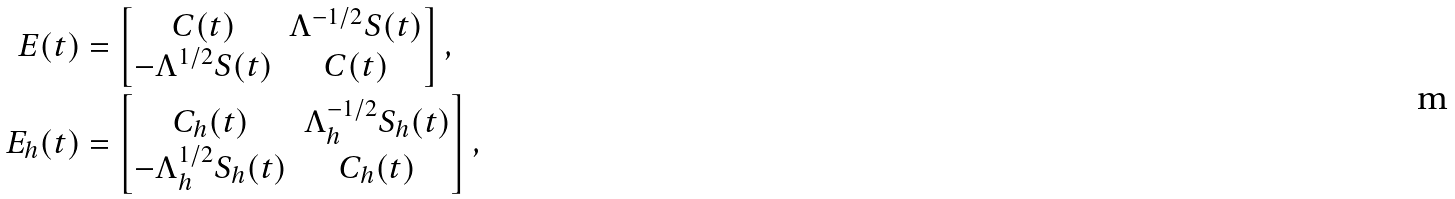Convert formula to latex. <formula><loc_0><loc_0><loc_500><loc_500>E ( t ) & = \begin{bmatrix} C ( t ) & \Lambda ^ { - 1 / 2 } S ( t ) \\ - \Lambda ^ { 1 / 2 } S ( t ) & C ( t ) \end{bmatrix} , \\ E _ { h } ( t ) & = \begin{bmatrix} C _ { h } ( t ) & \Lambda _ { h } ^ { - 1 / 2 } S _ { h } ( t ) \\ - \Lambda _ { h } ^ { 1 / 2 } S _ { h } ( t ) & C _ { h } ( t ) \end{bmatrix} ,</formula> 